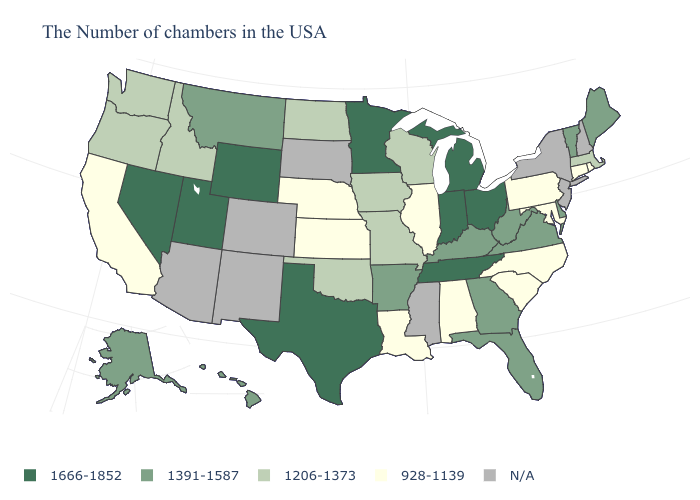What is the value of West Virginia?
Quick response, please. 1391-1587. What is the value of Washington?
Write a very short answer. 1206-1373. Does Florida have the highest value in the USA?
Concise answer only. No. What is the value of Virginia?
Give a very brief answer. 1391-1587. What is the lowest value in the USA?
Write a very short answer. 928-1139. What is the lowest value in the Northeast?
Keep it brief. 928-1139. How many symbols are there in the legend?
Short answer required. 5. What is the value of Utah?
Write a very short answer. 1666-1852. Does the map have missing data?
Answer briefly. Yes. Name the states that have a value in the range N/A?
Be succinct. New Hampshire, New York, New Jersey, Mississippi, South Dakota, Colorado, New Mexico, Arizona. What is the lowest value in the Northeast?
Quick response, please. 928-1139. What is the lowest value in the South?
Concise answer only. 928-1139. Among the states that border Utah , which have the highest value?
Quick response, please. Wyoming, Nevada. Which states hav the highest value in the West?
Write a very short answer. Wyoming, Utah, Nevada. What is the highest value in the MidWest ?
Concise answer only. 1666-1852. 